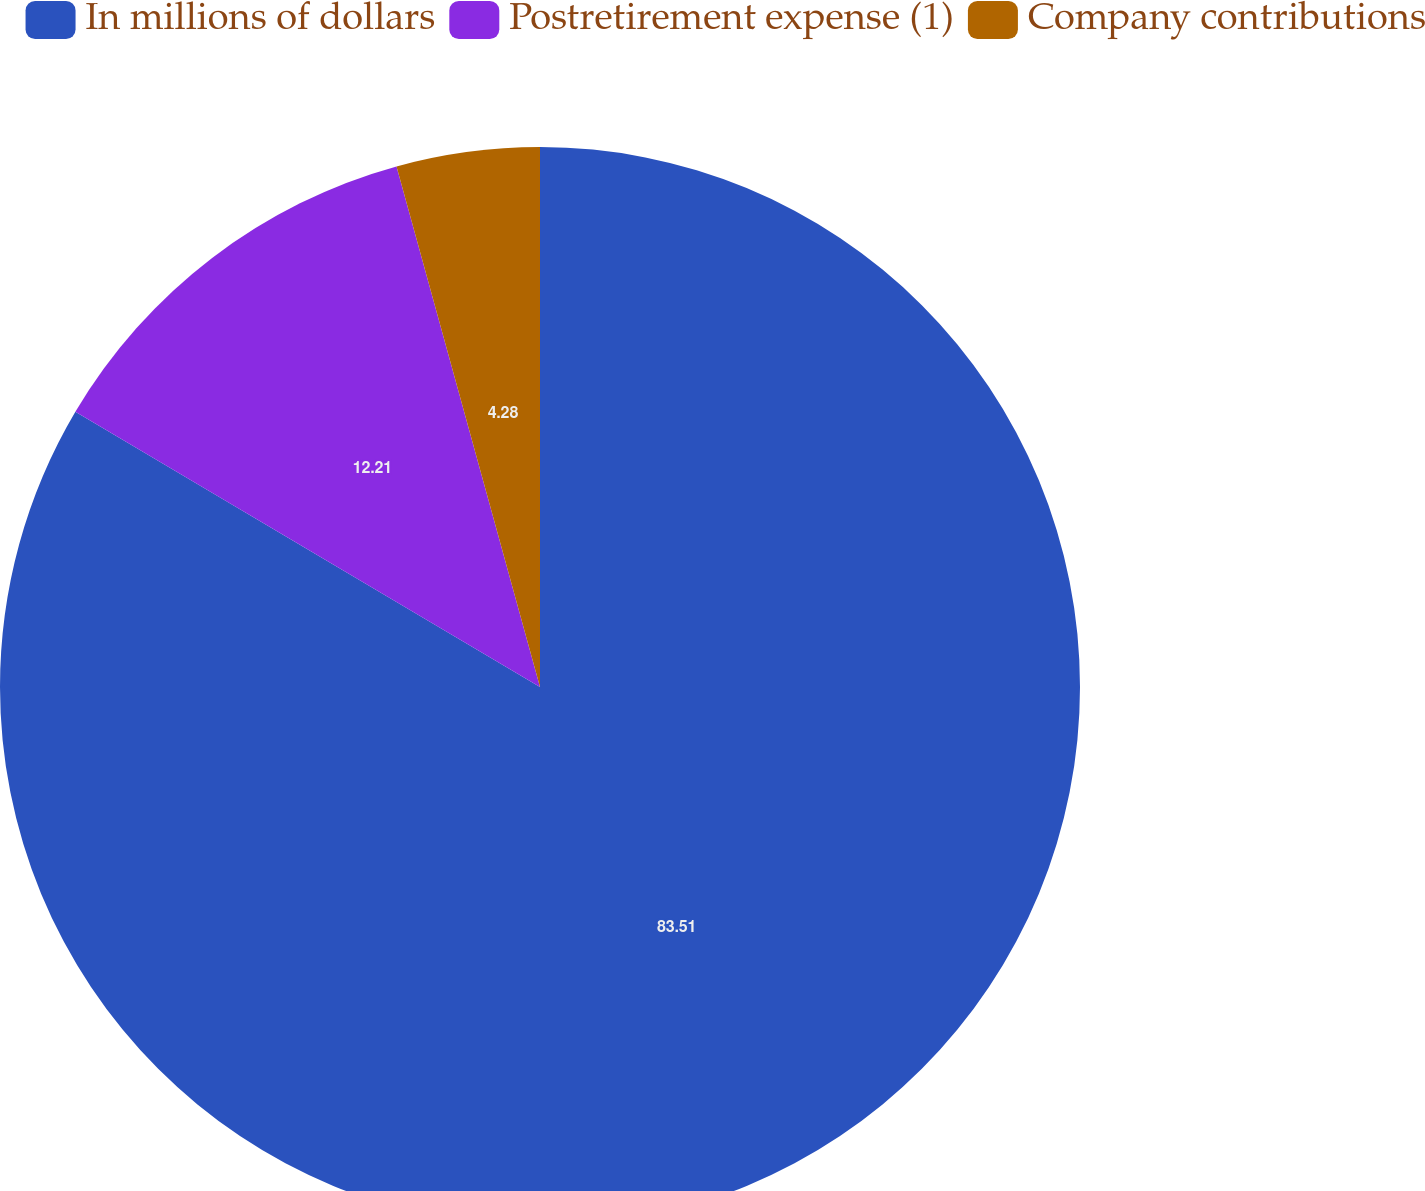Convert chart to OTSL. <chart><loc_0><loc_0><loc_500><loc_500><pie_chart><fcel>In millions of dollars<fcel>Postretirement expense (1)<fcel>Company contributions<nl><fcel>83.51%<fcel>12.21%<fcel>4.28%<nl></chart> 